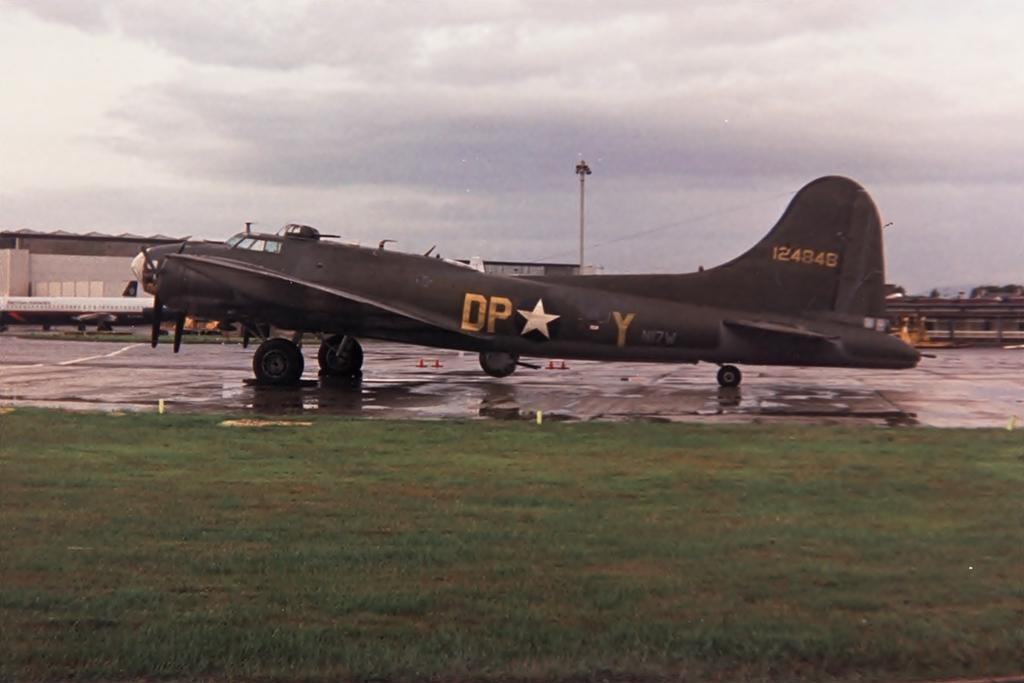<image>
Provide a brief description of the given image. A military with a large DP on the side sits on wet pavement. 